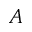<formula> <loc_0><loc_0><loc_500><loc_500>A</formula> 